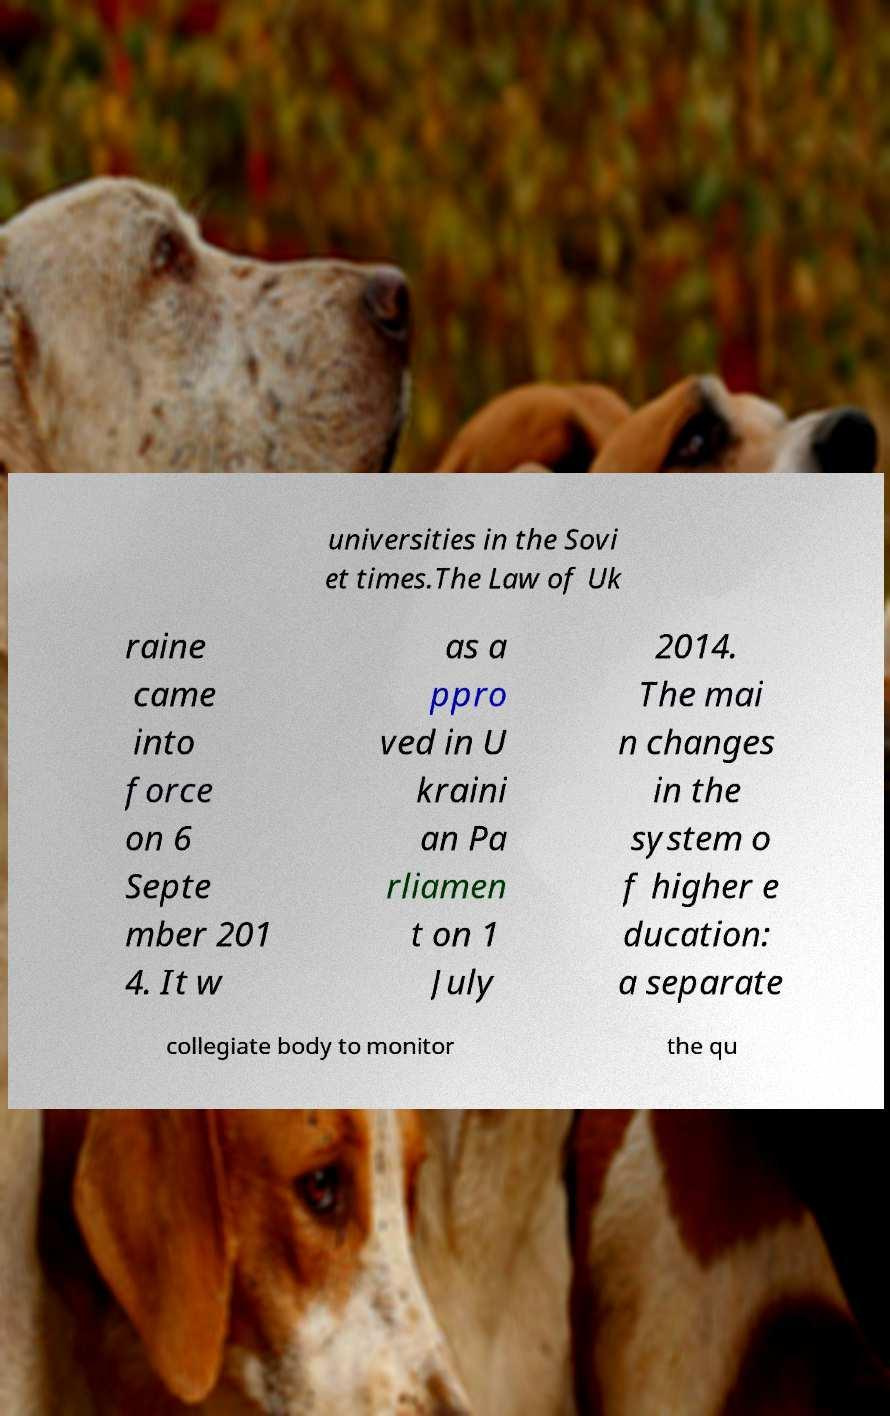Can you accurately transcribe the text from the provided image for me? universities in the Sovi et times.The Law of Uk raine came into force on 6 Septe mber 201 4. It w as a ppro ved in U kraini an Pa rliamen t on 1 July 2014. The mai n changes in the system o f higher e ducation: a separate collegiate body to monitor the qu 